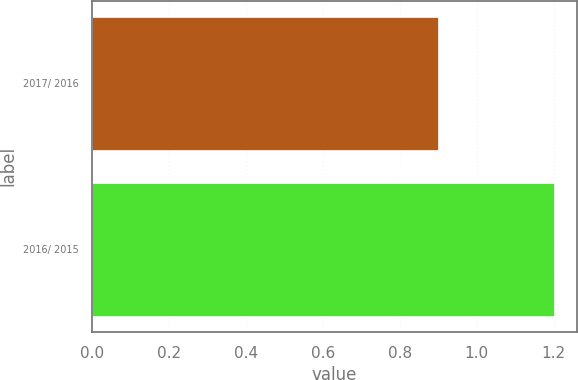Convert chart. <chart><loc_0><loc_0><loc_500><loc_500><bar_chart><fcel>2017/ 2016<fcel>2016/ 2015<nl><fcel>0.9<fcel>1.2<nl></chart> 